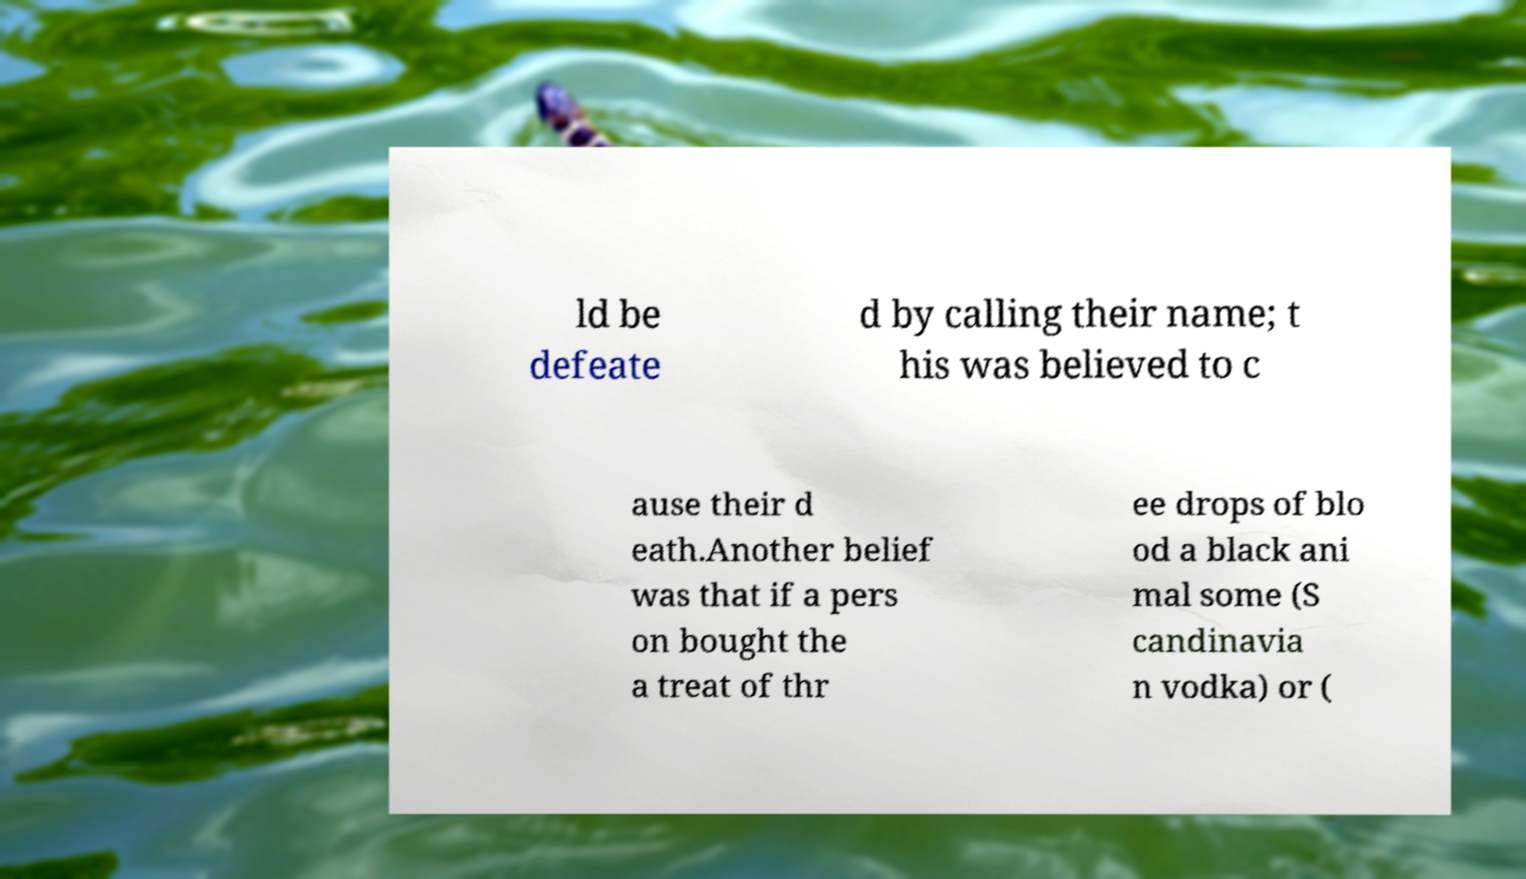There's text embedded in this image that I need extracted. Can you transcribe it verbatim? ld be defeate d by calling their name; t his was believed to c ause their d eath.Another belief was that if a pers on bought the a treat of thr ee drops of blo od a black ani mal some (S candinavia n vodka) or ( 